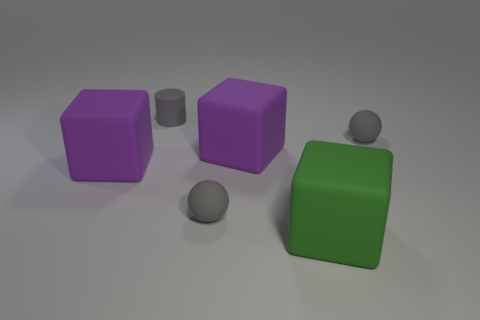Add 3 purple matte things. How many objects exist? 9 Subtract all cylinders. How many objects are left? 5 Subtract all small gray cylinders. Subtract all big purple matte blocks. How many objects are left? 3 Add 2 gray cylinders. How many gray cylinders are left? 3 Add 4 gray matte things. How many gray matte things exist? 7 Subtract 0 purple cylinders. How many objects are left? 6 